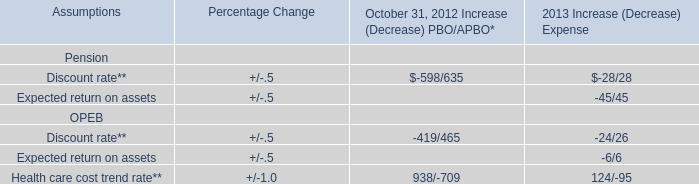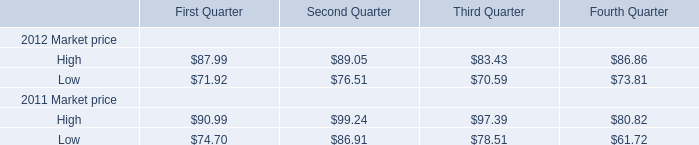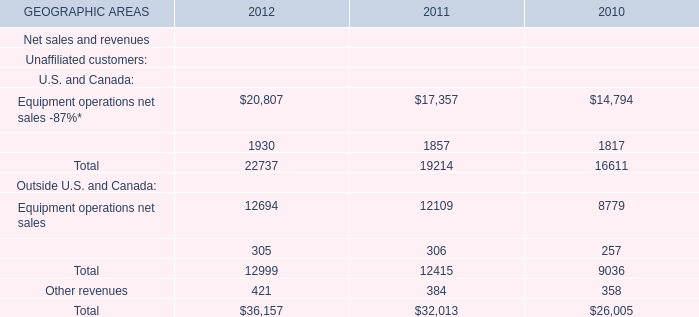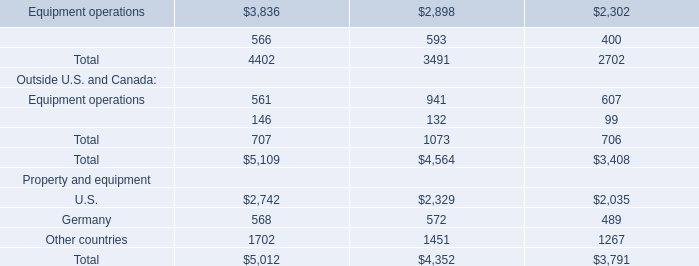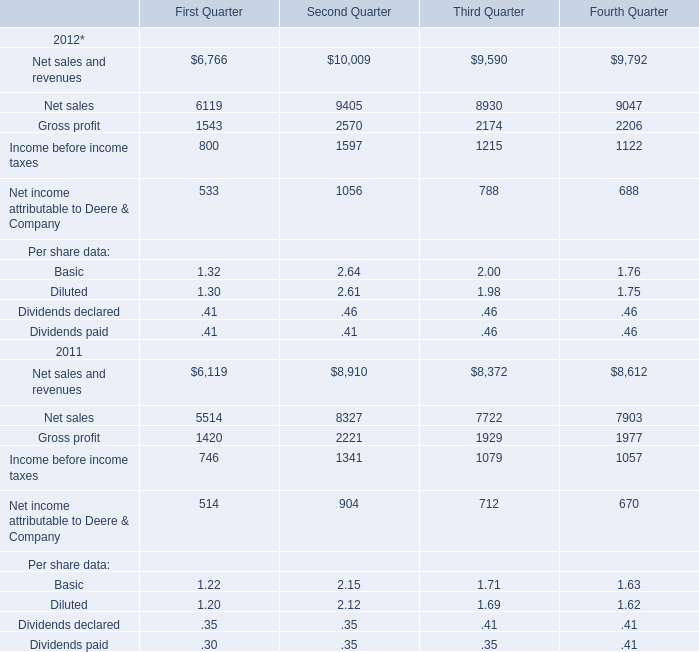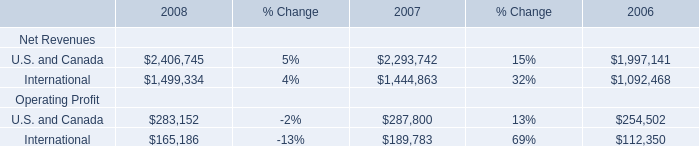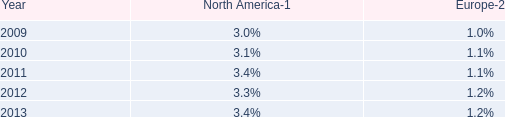What will (12694-12109)/12109 reach in 2013 if it continues to grow at its current rate? 
Computations: ((1 + ((12694 - 12109) / 12109)) * 12694)
Answer: 13307.26204. 